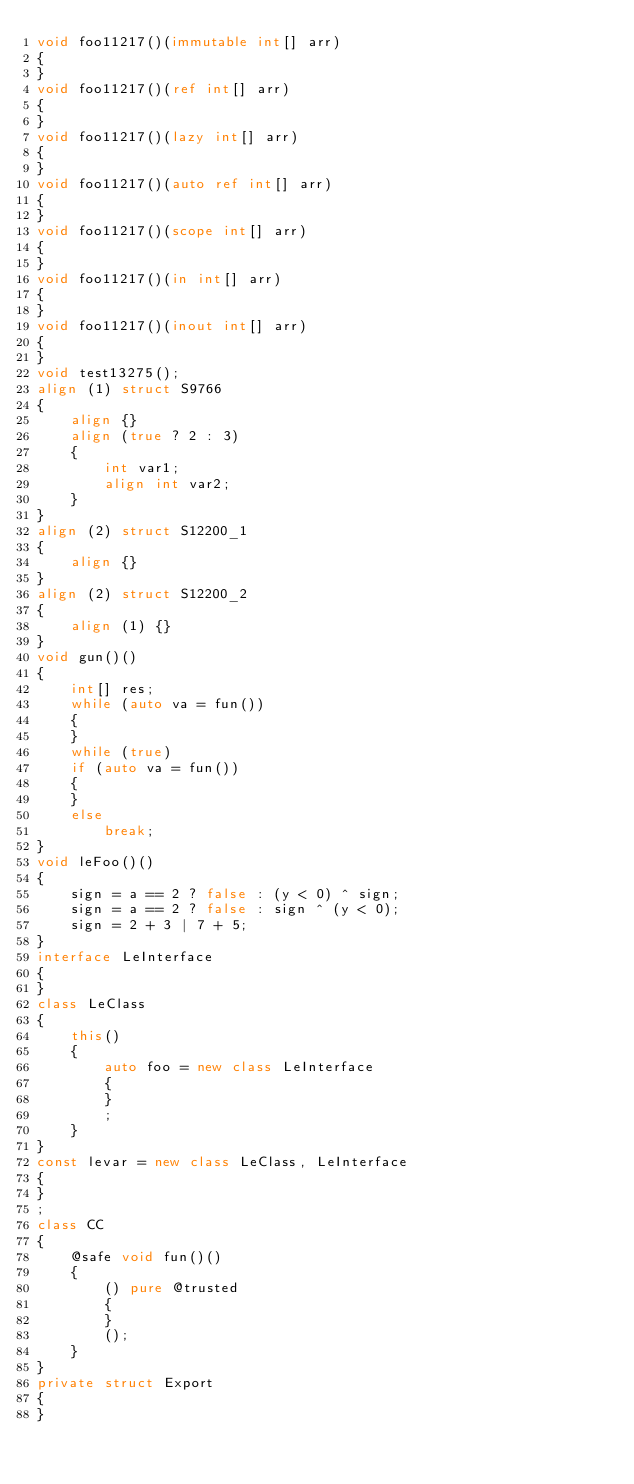<code> <loc_0><loc_0><loc_500><loc_500><_D_>void foo11217()(immutable int[] arr)
{
}
void foo11217()(ref int[] arr)
{
}
void foo11217()(lazy int[] arr)
{
}
void foo11217()(auto ref int[] arr)
{
}
void foo11217()(scope int[] arr)
{
}
void foo11217()(in int[] arr)
{
}
void foo11217()(inout int[] arr)
{
}
void test13275();
align (1) struct S9766
{
	align {}
	align (true ? 2 : 3)
	{
		int var1;
		align int var2;
	}
}
align (2) struct S12200_1
{
	align {}
}
align (2) struct S12200_2
{
	align (1) {}
}
void gun()()
{
	int[] res;
	while (auto va = fun())
	{
	}
	while (true)
	if (auto va = fun())
	{
	}
	else
		break;
}
void leFoo()()
{
	sign = a == 2 ? false : (y < 0) ^ sign;
	sign = a == 2 ? false : sign ^ (y < 0);
	sign = 2 + 3 | 7 + 5;
}
interface LeInterface
{
}
class LeClass
{
	this()
	{
		auto foo = new class LeInterface
		{
		}
		;
	}
}
const levar = new class LeClass, LeInterface
{
}
;
class CC
{
	@safe void fun()()
	{
		() pure @trusted
		{
		}
		();
	}
}
private struct Export
{
}
</code> 